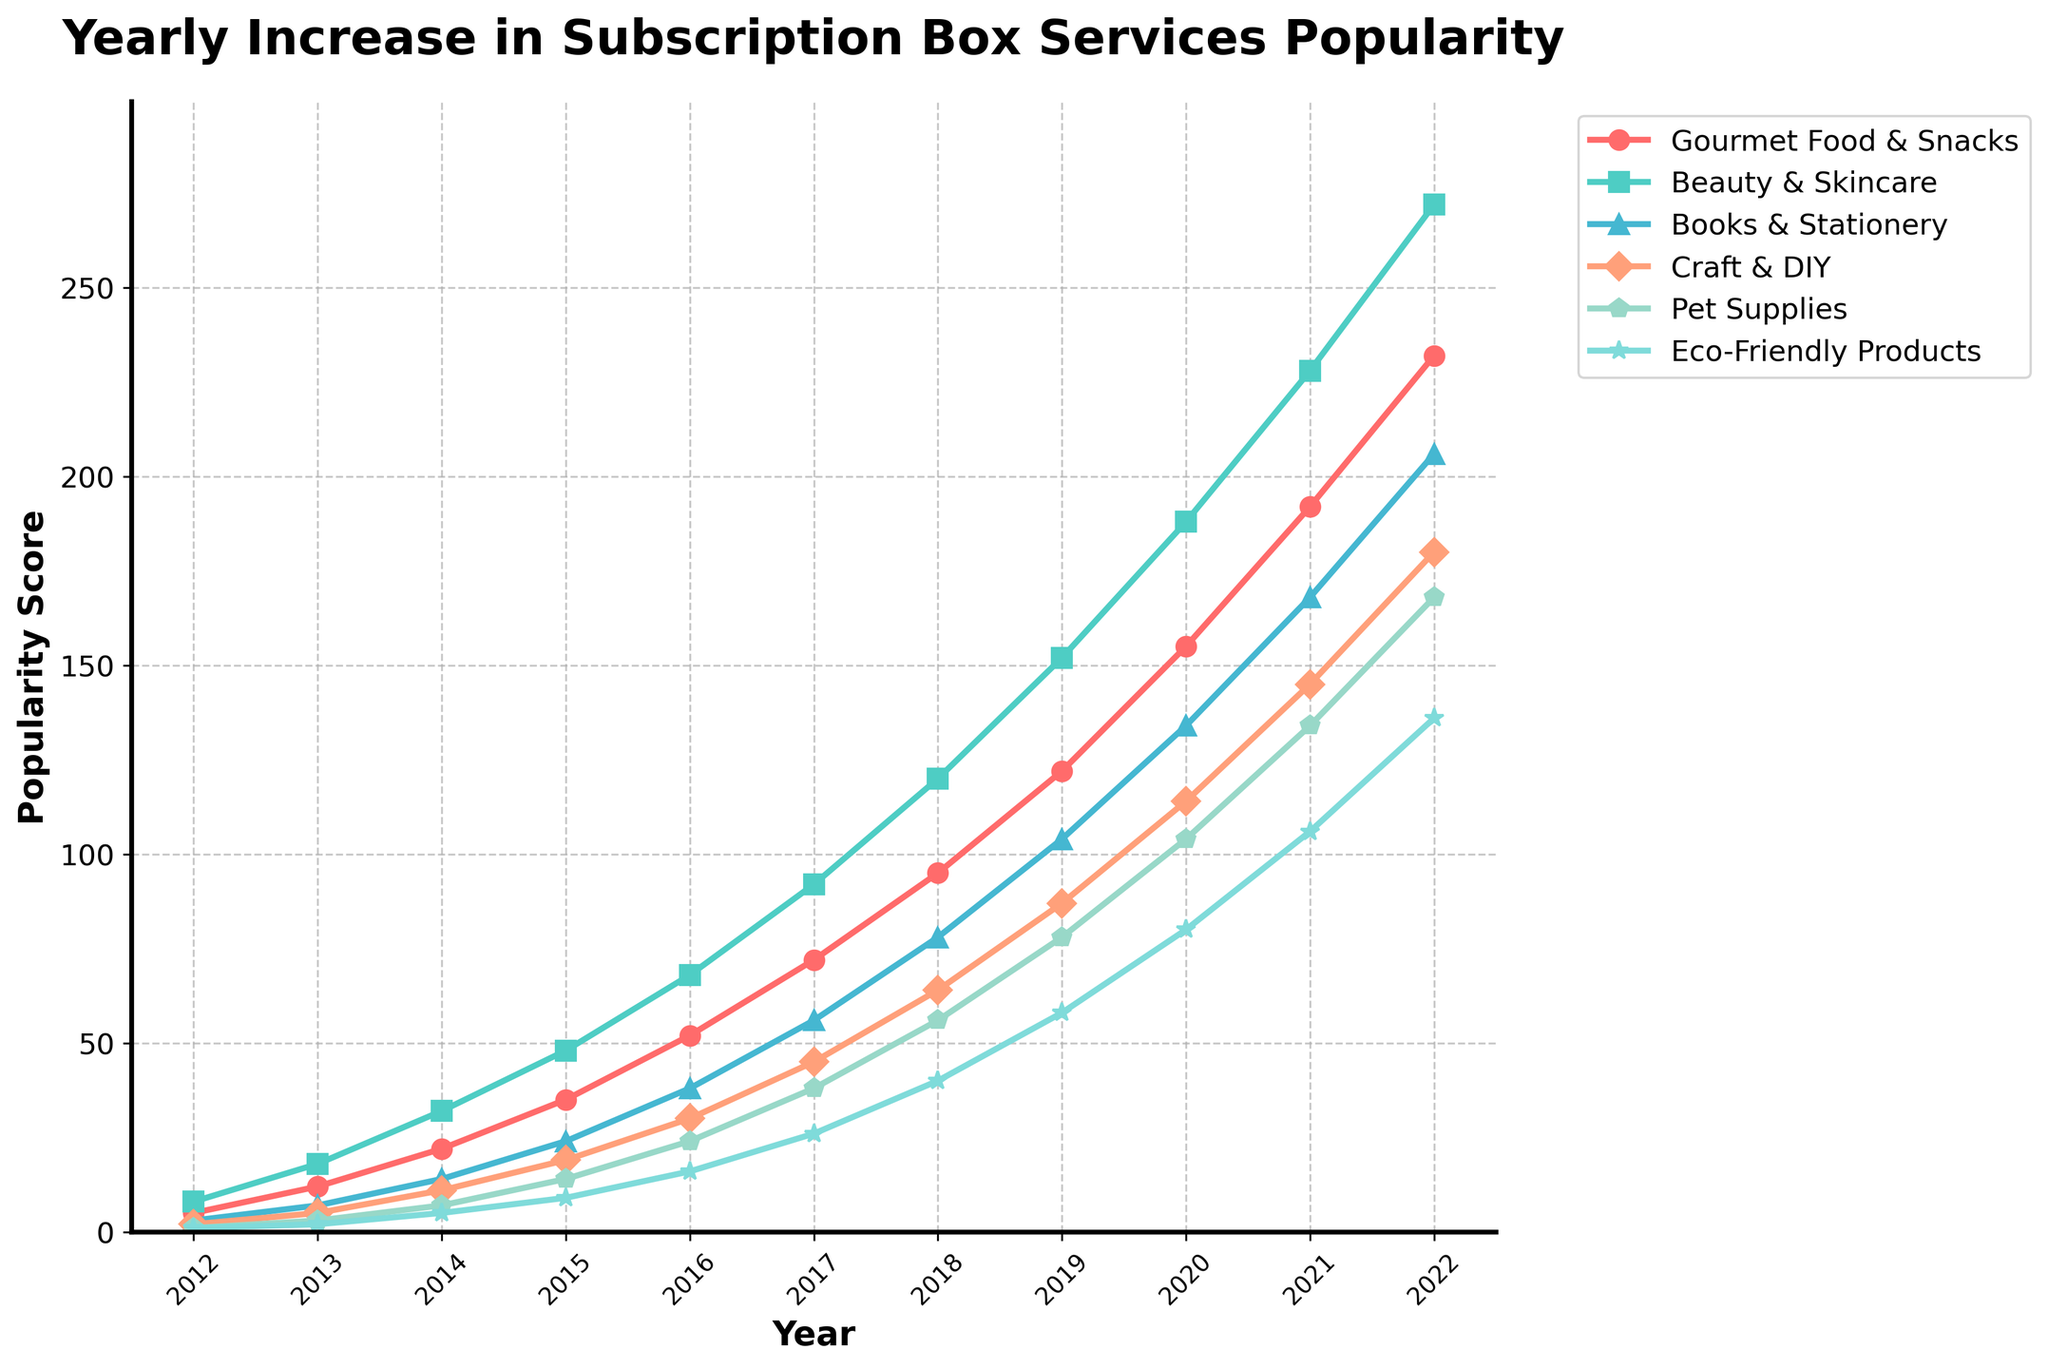What was the most popular gift category in 2022? By examining the end of the plot for the year 2022, the highest line corresponds to "Gourmet Food & Snacks".
Answer: Gourmet Food & Snacks Which gift category had the least popularity in 2012? Observing the starting points for the year 2012, the lowest point on the chart is for "Eco-Friendly Products".
Answer: Eco-Friendly Products How much did the popularity of Beauty & Skincare increase from 2016 to 2020? In 2016, the popularity was 68, and in 2020, it was 188. Subtract the 2016 value from the 2020 value, i.e., 188 - 68.
Answer: 120 In which year did Books & Stationery surpass 100 in popularity? The popularity line for Books & Stationery crosses the 100 mark between 2018 and 2019. By 2019, it reaches 104.
Answer: 2019 How does the growth trend of Craft & DIY compare to Eco-Friendly Products over the entire period? The chart shows that Craft & DIY consistently grows faster and steeper compared to the Eco-Friendly Products line throughout the period, indicating stronger growth.
Answer: Faster and steeper growth By how much did the popularity of Pet Supplies increase from 2018 to 2022? In 2018, Pet Supplies was at 56, and by 2022, it reaches 168. Calculate the difference: 168 - 56.
Answer: 112 Which gift category showed the second highest growth in popularity from 2012 to 2022? First, calculate the growth for each category over this period: subtract the 2012 value from the 2022 value for each. 
  - Gourmet Food & Snacks: 232 - 5 = 227
  - Beauty & Skincare: 272 - 8 = 264
  - Books & Stationery: 206 - 3 = 203
  - Craft & DIY: 180 - 2 = 178
  - Pet Supplies: 168 - 1 = 167
  - Eco-Friendly Products: 136 - 1 = 135
  The second highest growth is for Beauty & Skincare (264).
Answer: Beauty & Skincare What is the average popularity of Books & Stationery over the recorded years? Add up the popularity values for Books & Stationery from 2012 to 2022 and divide by the total number of years (11).
  (3 + 7 + 14 + 24 + 38 + 56 + 78 + 104 + 134 + 168 + 206) / 11 = 83.27
Answer: 83.27 When did Eco-Friendly Products first reach 50 in popularity? Check the line for Eco-Friendly Products and identify the year it first hits or surpasses 50. This happens between 2019 and 2020, by 2020 it has a popularity of 80.
Answer: 2020 Compare the popularity growth of Gourmet Food & Snacks with Books & Stationery between 2014 and 2018. For Gourmet Food & Snacks, in 2014: 22 and in 2018: 95. Growth is: 95 - 22 = 73.
For Books & Stationery, in 2014: 14 and in 2018: 78. Growth is: 78 - 14 = 64.
So, Gourmet Food & Snacks grew by 73, and Books & Stationery grew by 64.
Answer: Gourmet Food & Snacks: 73, Books & Stationery: 64 